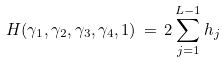<formula> <loc_0><loc_0><loc_500><loc_500>H ( \gamma _ { 1 } , \gamma _ { 2 } , \gamma _ { 3 } , \gamma _ { 4 } , 1 ) \, = \, 2 \sum _ { j = 1 } ^ { L - 1 } h _ { j }</formula> 